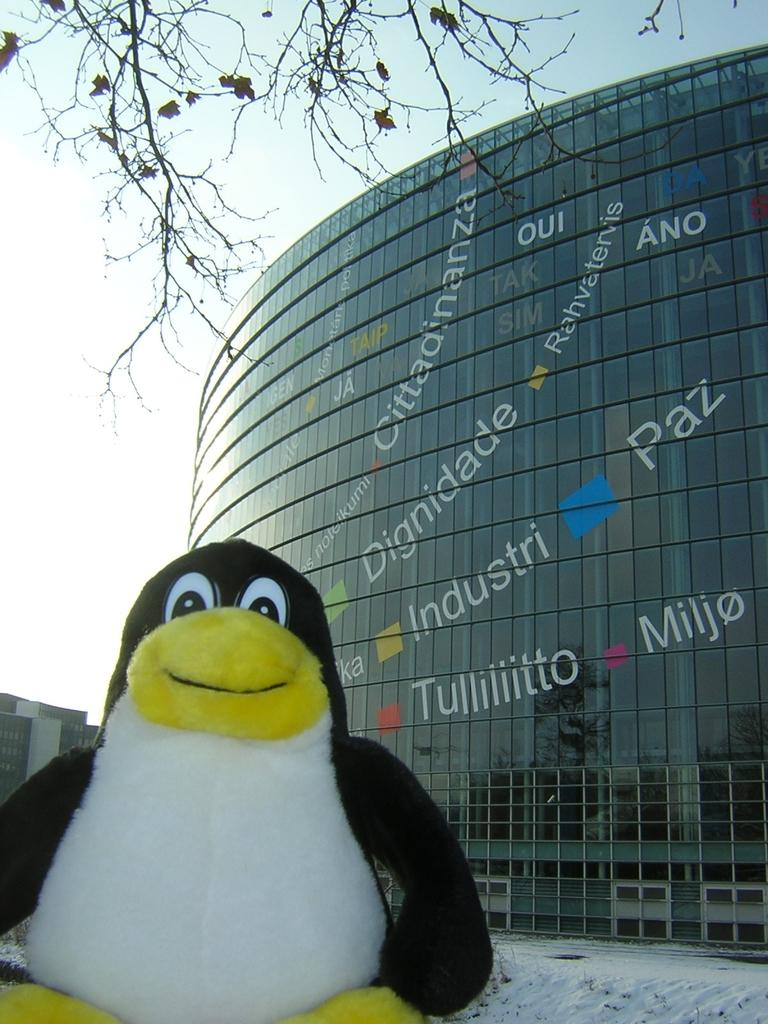What type of toy is in the image? There is a toy penguin in the image. What is the toy penguin doing in the image? The toy penguin is standing on the ground. What is the ground covered with in the image? The ground is covered with snow. What can be seen in the background of the image? There is a building in the background of the image. What is visible at the top of the image? There is a tree visible at the top of the image. How much payment is required to enter the tree in the image? There is no payment required to enter the tree in the image, as it is not a physical location or structure that one can enter. 